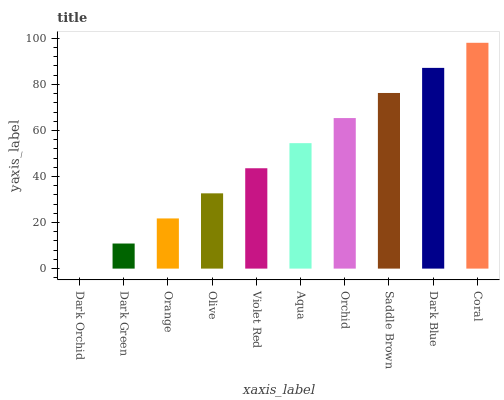Is Dark Orchid the minimum?
Answer yes or no. Yes. Is Coral the maximum?
Answer yes or no. Yes. Is Dark Green the minimum?
Answer yes or no. No. Is Dark Green the maximum?
Answer yes or no. No. Is Dark Green greater than Dark Orchid?
Answer yes or no. Yes. Is Dark Orchid less than Dark Green?
Answer yes or no. Yes. Is Dark Orchid greater than Dark Green?
Answer yes or no. No. Is Dark Green less than Dark Orchid?
Answer yes or no. No. Is Aqua the high median?
Answer yes or no. Yes. Is Violet Red the low median?
Answer yes or no. Yes. Is Saddle Brown the high median?
Answer yes or no. No. Is Orange the low median?
Answer yes or no. No. 